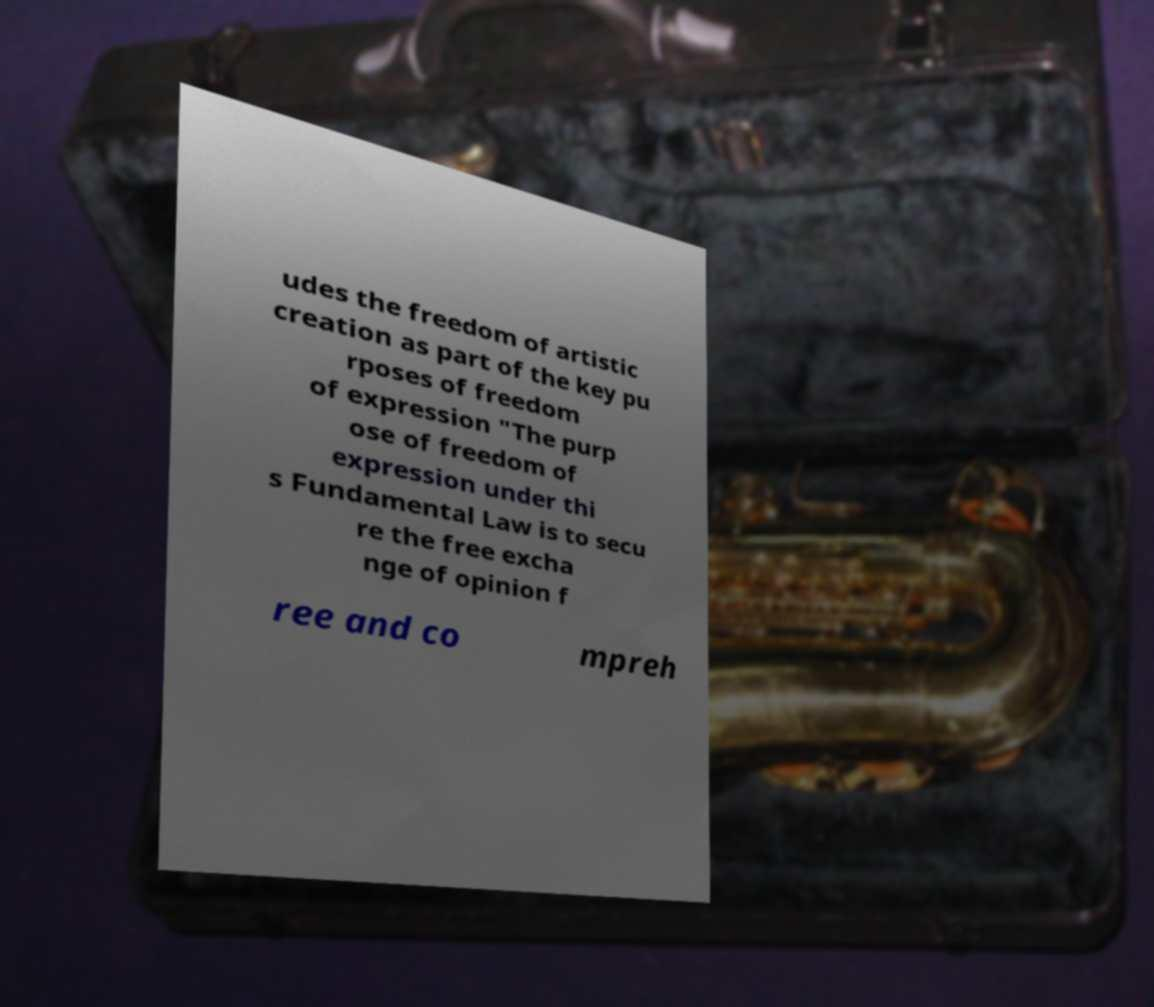I need the written content from this picture converted into text. Can you do that? udes the freedom of artistic creation as part of the key pu rposes of freedom of expression "The purp ose of freedom of expression under thi s Fundamental Law is to secu re the free excha nge of opinion f ree and co mpreh 